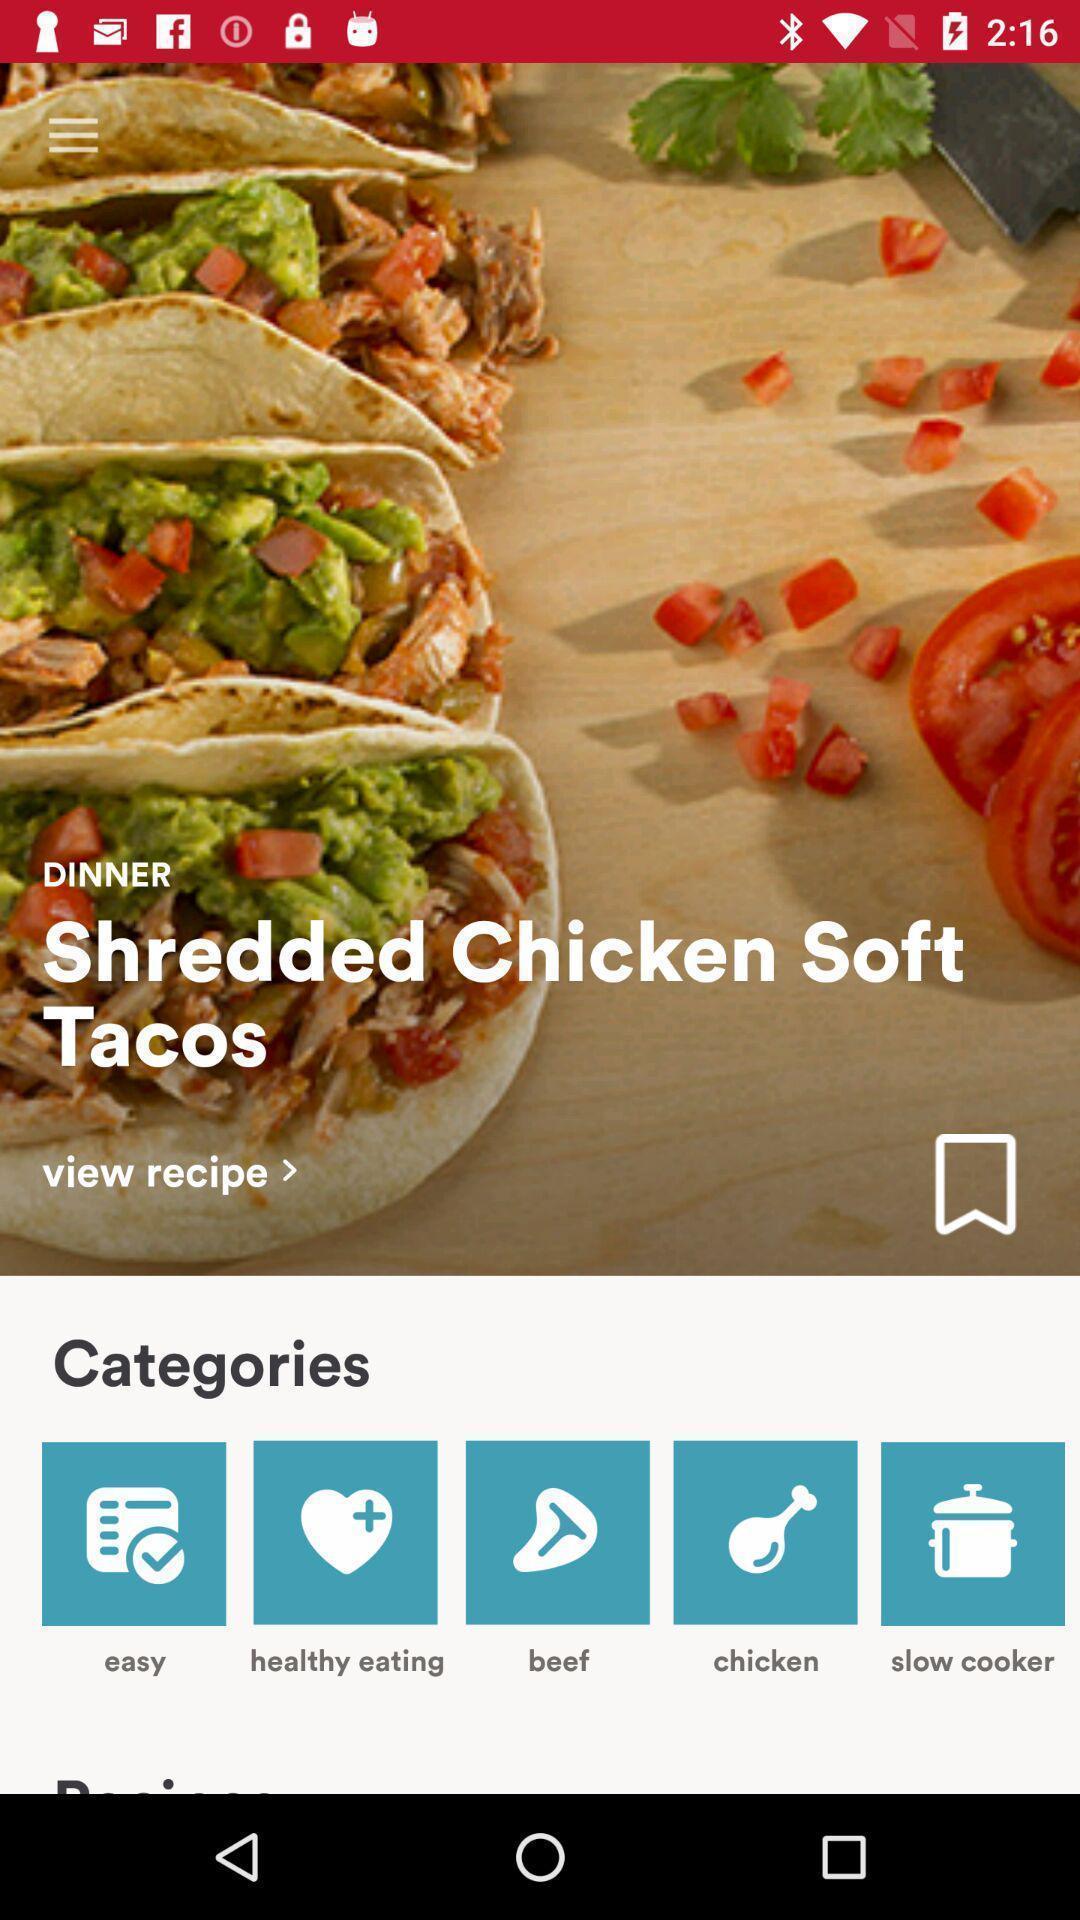Summarize the information in this screenshot. Screen shows different options in cooking app. 